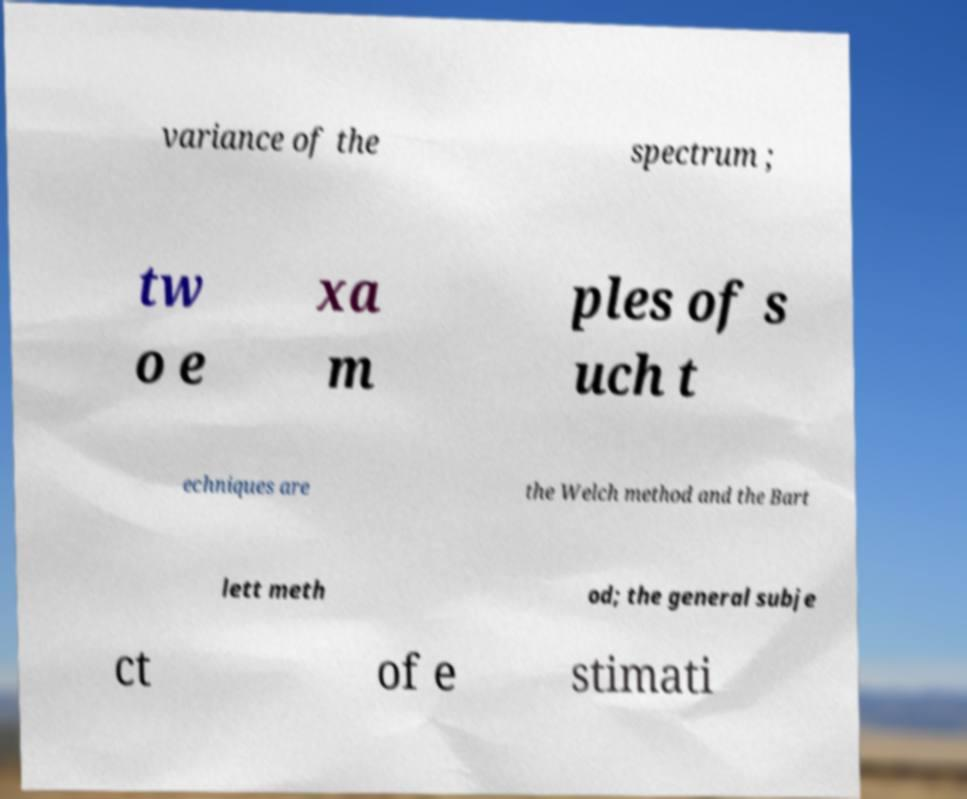What messages or text are displayed in this image? I need them in a readable, typed format. variance of the spectrum ; tw o e xa m ples of s uch t echniques are the Welch method and the Bart lett meth od; the general subje ct of e stimati 